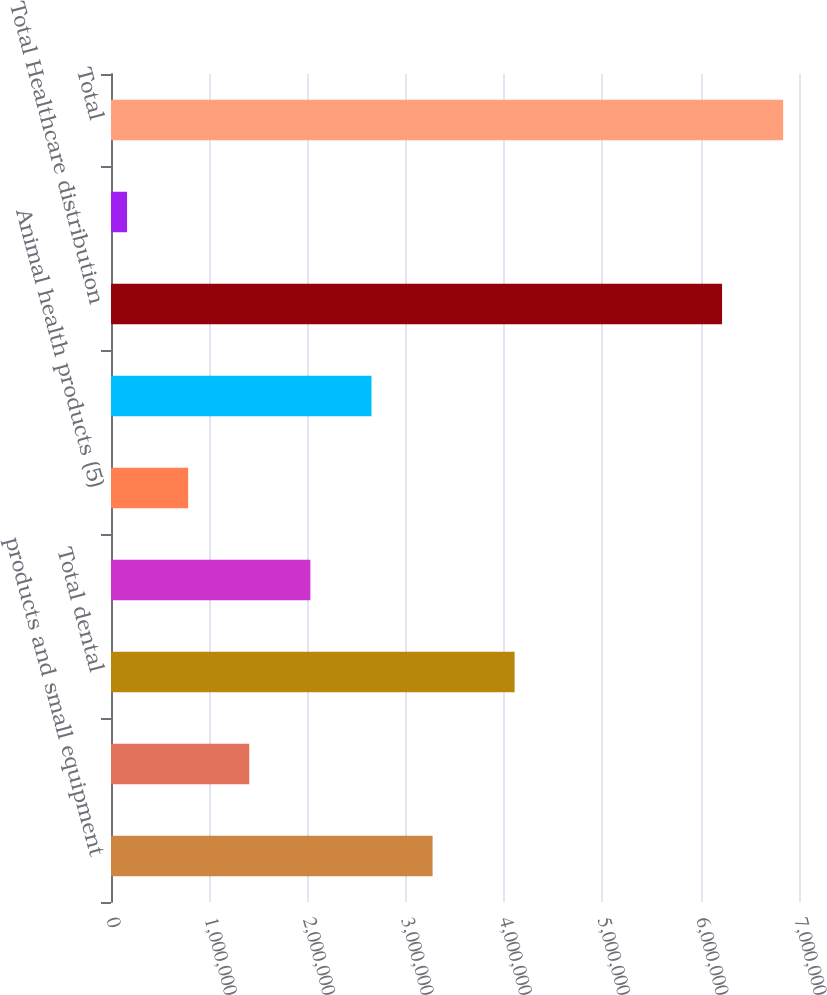<chart> <loc_0><loc_0><loc_500><loc_500><bar_chart><fcel>products and small equipment<fcel>Large dental equipment (3)<fcel>Total dental<fcel>Medical products (4)<fcel>Animal health products (5)<fcel>Total medical<fcel>Total Healthcare distribution<fcel>other value-added products (6)<fcel>Total<nl><fcel>3.27185e+06<fcel>1.40671e+06<fcel>4.1066e+06<fcel>2.02843e+06<fcel>785001<fcel>2.65014e+06<fcel>6.21712e+06<fcel>163289<fcel>6.83884e+06<nl></chart> 